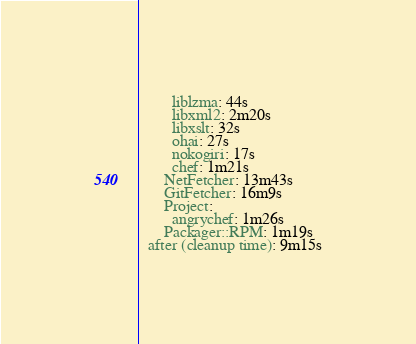Convert code to text. <code><loc_0><loc_0><loc_500><loc_500><_YAML_>        liblzma: 44s
        libxml2: 2m20s
        libxslt: 32s
        ohai: 27s
        nokogiri: 17s
        chef: 1m21s
      NetFetcher: 13m43s
      GitFetcher: 16m9s
      Project:
        angrychef: 1m26s
      Packager::RPM: 1m19s
  after (cleanup time): 9m15s
</code> 